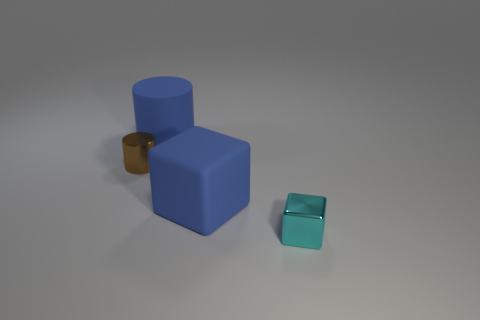Subtract all red cubes. Subtract all gray cylinders. How many cubes are left? 2 Add 3 cylinders. How many objects exist? 7 Subtract all big cylinders. Subtract all small gray shiny balls. How many objects are left? 3 Add 4 rubber objects. How many rubber objects are left? 6 Add 1 big cylinders. How many big cylinders exist? 2 Subtract 0 gray blocks. How many objects are left? 4 